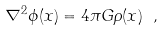<formula> <loc_0><loc_0><loc_500><loc_500>\nabla ^ { 2 } \phi ( { x } ) = 4 \pi G \rho ( { x } ) \ ,</formula> 